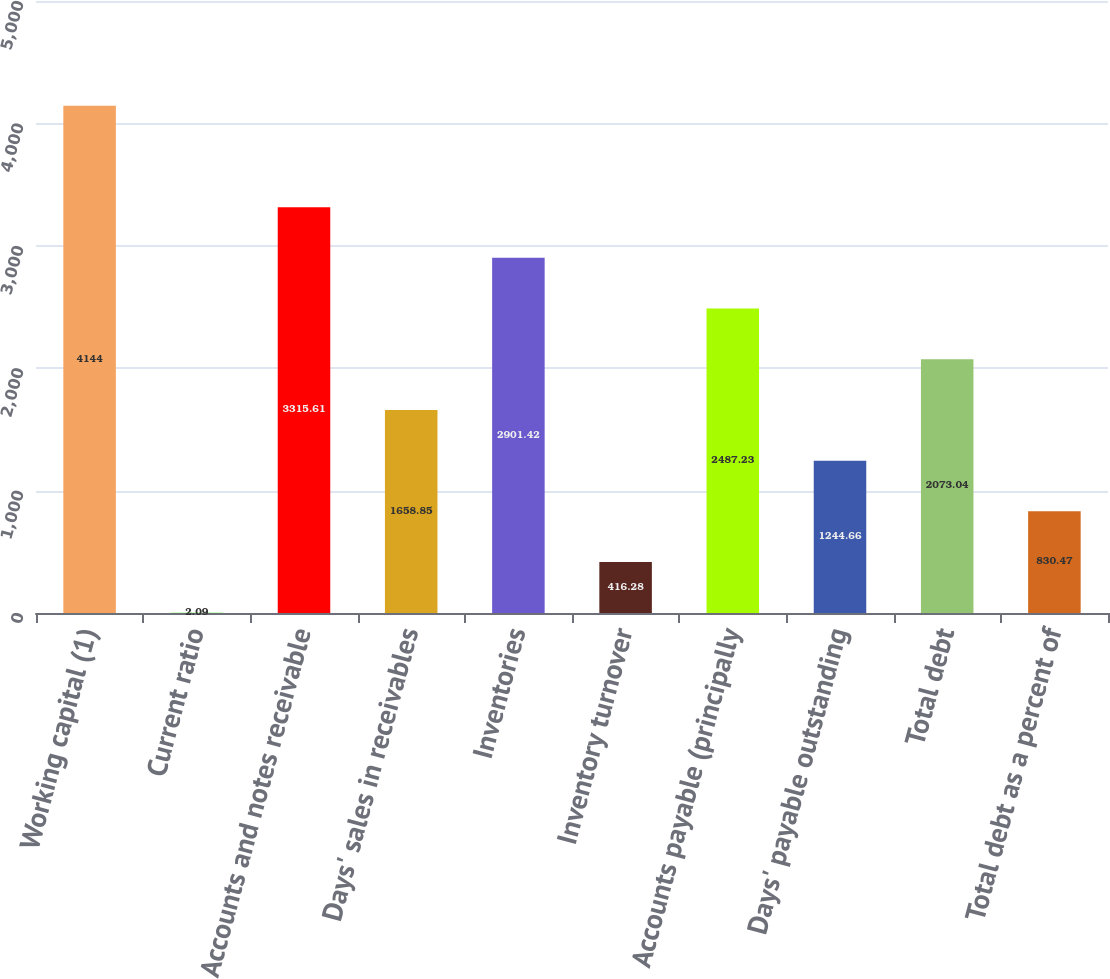Convert chart to OTSL. <chart><loc_0><loc_0><loc_500><loc_500><bar_chart><fcel>Working capital (1)<fcel>Current ratio<fcel>Accounts and notes receivable<fcel>Days' sales in receivables<fcel>Inventories<fcel>Inventory turnover<fcel>Accounts payable (principally<fcel>Days' payable outstanding<fcel>Total debt<fcel>Total debt as a percent of<nl><fcel>4144<fcel>2.09<fcel>3315.61<fcel>1658.85<fcel>2901.42<fcel>416.28<fcel>2487.23<fcel>1244.66<fcel>2073.04<fcel>830.47<nl></chart> 